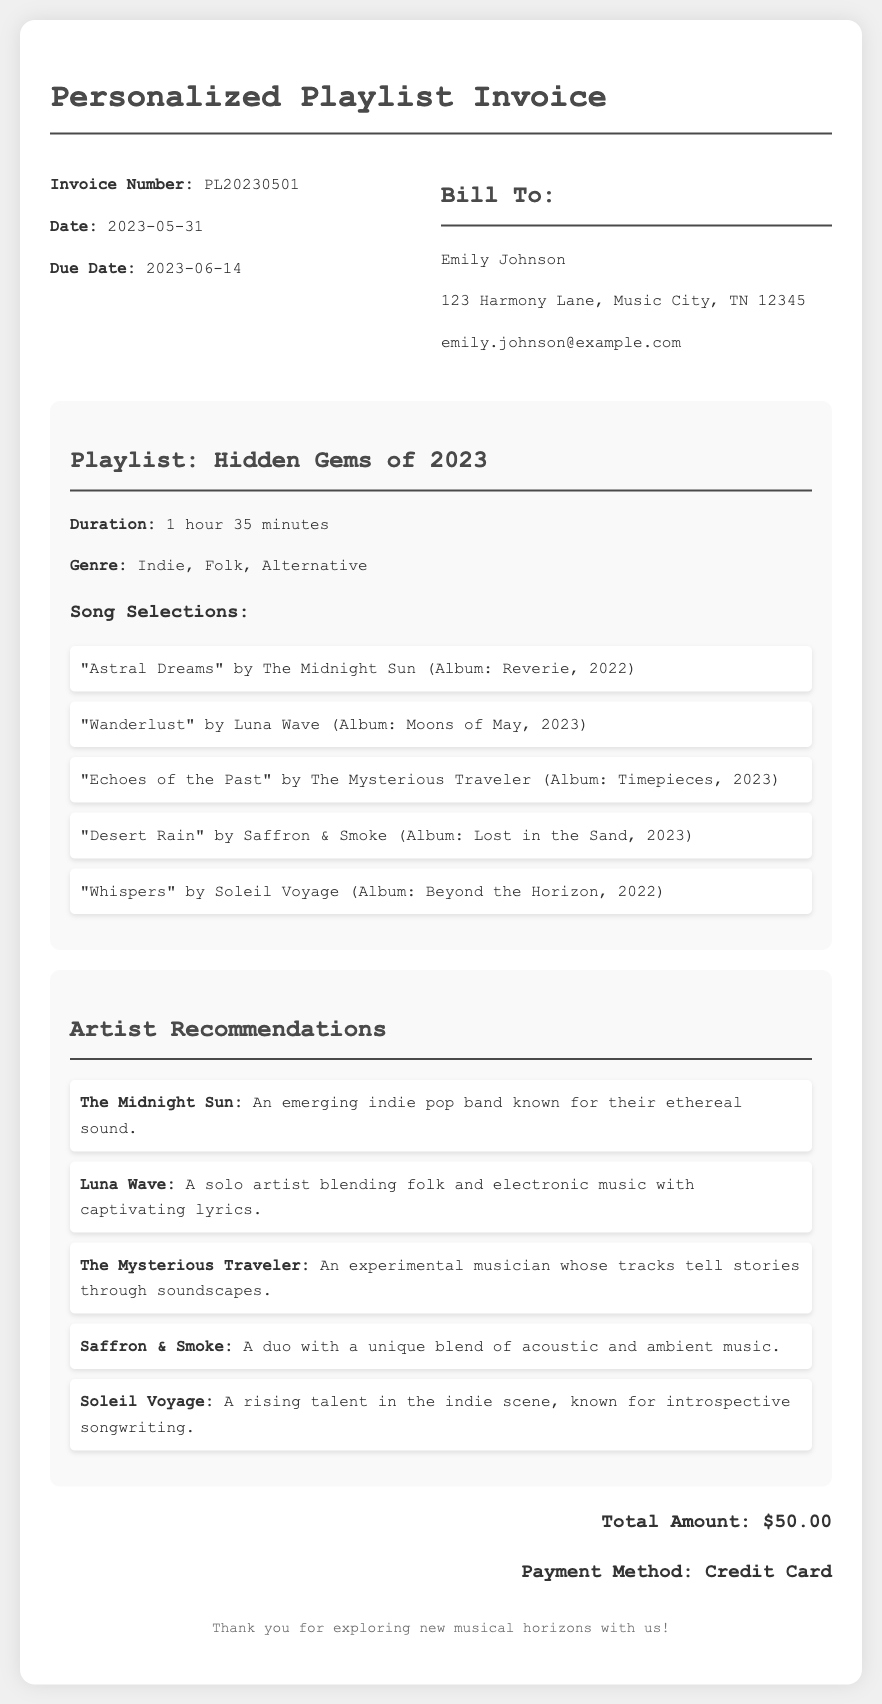what is the invoice number? The invoice number is specifically mentioned in the document as PL20230501.
Answer: PL20230501 what is the date of the invoice? The date of the invoice is provided in the document as May 31, 2023.
Answer: 2023-05-31 who is the bill to? The document lists the recipient as Emily Johnson, which is specified under "Bill To."
Answer: Emily Johnson what is the duration of the playlist? The duration of the playlist is stated in the document as 1 hour 35 minutes.
Answer: 1 hour 35 minutes name one song included in the playlist. The document lists several songs, including "Astral Dreams" by The Midnight Sun as an example from the playlist selections.
Answer: "Astral Dreams" how many artist recommendations are provided? The document includes a total of 5 artist recommendations in the specified section.
Answer: 5 what genre is the playlist? The document categorizes the playlist under the genre of Indie, Folk, Alternative.
Answer: Indie, Folk, Alternative what is the total amount due? The total amount due at the end of the document is specified as $50.00.
Answer: $50.00 which payment method was used? The payment method listed in the document indicates that a credit card was used for the transaction.
Answer: Credit Card 